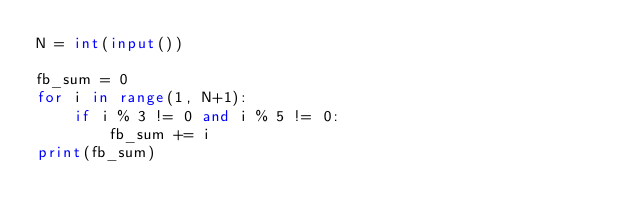<code> <loc_0><loc_0><loc_500><loc_500><_Python_>N = int(input())

fb_sum = 0
for i in range(1, N+1):
    if i % 3 != 0 and i % 5 != 0:
        fb_sum += i
print(fb_sum)
</code> 